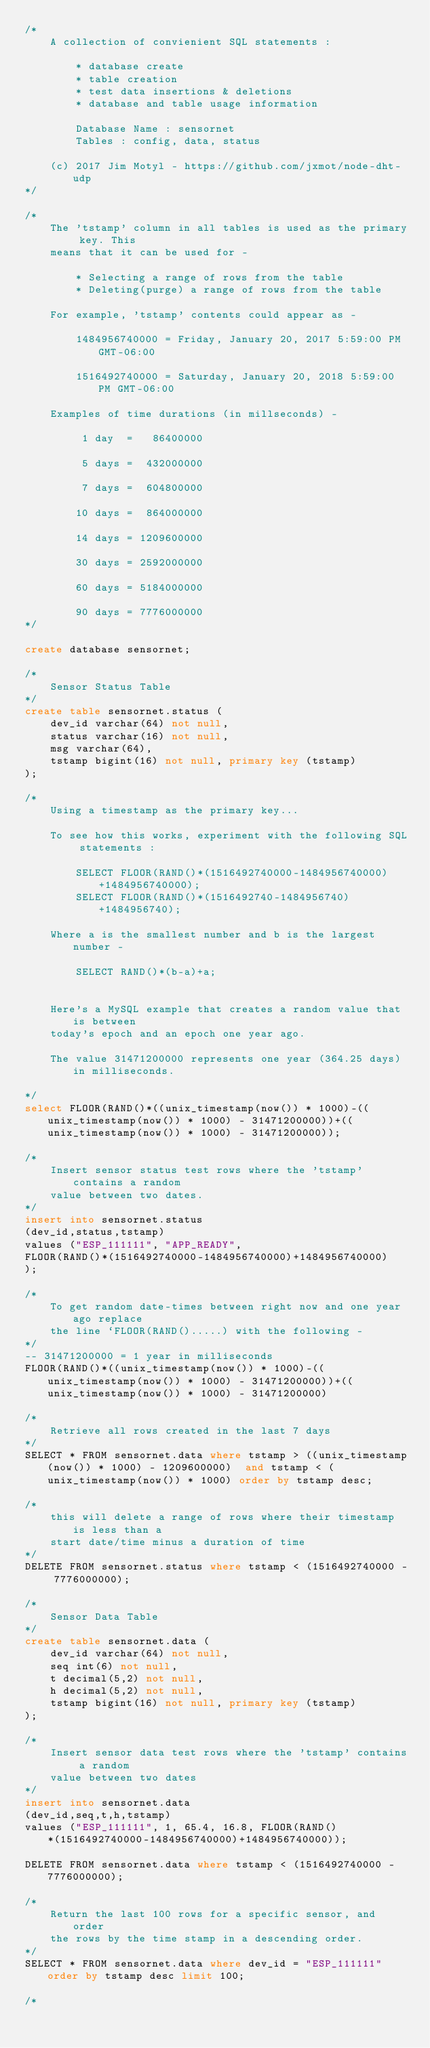<code> <loc_0><loc_0><loc_500><loc_500><_SQL_>/*
    A collection of convienient SQL statements :

        * database create
        * table creation
        * test data insertions & deletions
        * database and table usage information

        Database Name : sensornet
        Tables : config, data, status

    (c) 2017 Jim Motyl - https://github.com/jxmot/node-dht-udp
*/

/*
    The 'tstamp' column in all tables is used as the primary key. This 
    means that it can be used for - 

        * Selecting a range of rows from the table
        * Deleting(purge) a range of rows from the table

    For example, 'tstamp' contents could appear as - 

        1484956740000 = Friday, January 20, 2017 5:59:00 PM GMT-06:00
        
        1516492740000 = Saturday, January 20, 2018 5:59:00 PM GMT-06:00

    Examples of time durations (in millseconds) -

         1 day  =   86400000
        
         5 days =  432000000

         7 days =  604800000
        
        10 days =  864000000
        
        14 days = 1209600000
        
        30 days = 2592000000
        
        60 days = 5184000000
        
        90 days = 7776000000
*/

create database sensornet;

/*
    Sensor Status Table
*/
create table sensornet.status (
    dev_id varchar(64) not null,
    status varchar(16) not null,
    msg varchar(64),
    tstamp bigint(16) not null, primary key (tstamp) 
);

/*
    Using a timestamp as the primary key...

    To see how this works, experiment with the following SQL statements :

        SELECT FLOOR(RAND()*(1516492740000-1484956740000)+1484956740000);
        SELECT FLOOR(RAND()*(1516492740-1484956740)+1484956740);

    Where a is the smallest number and b is the largest number - 

        SELECT RAND()*(b-a)+a;


    Here's a MySQL example that creates a random value that is between
    today's epoch and an epoch one year ago.

    The value 31471200000 represents one year (364.25 days) in milliseconds.

*/
select FLOOR(RAND()*((unix_timestamp(now()) * 1000)-((unix_timestamp(now()) * 1000) - 31471200000))+((unix_timestamp(now()) * 1000) - 31471200000));

/*
    Insert sensor status test rows where the 'tstamp' contains a random
    value between two dates.
*/
insert into sensornet.status 
(dev_id,status,tstamp)
values ("ESP_111111", "APP_READY", 
FLOOR(RAND()*(1516492740000-1484956740000)+1484956740000)
);

/*
    To get random date-times between right now and one year ago replace
    the line `FLOOR(RAND().....) with the following - 
*/
-- 31471200000 = 1 year in milliseconds
FLOOR(RAND()*((unix_timestamp(now()) * 1000)-((unix_timestamp(now()) * 1000) - 31471200000))+((unix_timestamp(now()) * 1000) - 31471200000)

/*
    Retrieve all rows created in the last 7 days
*/
SELECT * FROM sensornet.data where tstamp > ((unix_timestamp(now()) * 1000) - 1209600000)  and tstamp < (unix_timestamp(now()) * 1000) order by tstamp desc;

/*
    this will delete a range of rows where their timestamp is less than a
    start date/time minus a duration of time
*/
DELETE FROM sensornet.status where tstamp < (1516492740000 - 7776000000);

/*
    Sensor Data Table
*/
create table sensornet.data (
    dev_id varchar(64) not null,
    seq int(6) not null,
    t decimal(5,2) not null,
    h decimal(5,2) not null,
    tstamp bigint(16) not null, primary key (tstamp) 
);

/*
    Insert sensor data test rows where the 'tstamp' contains a random
    value between two dates
*/
insert into sensornet.data 
(dev_id,seq,t,h,tstamp)
values ("ESP_111111", 1, 65.4, 16.8, FLOOR(RAND()*(1516492740000-1484956740000)+1484956740000));

DELETE FROM sensornet.data where tstamp < (1516492740000 - 7776000000);

/*
    Return the last 100 rows for a specific sensor, and order 
    the rows by the time stamp in a descending order.
*/
SELECT * FROM sensornet.data where dev_id = "ESP_111111" order by tstamp desc limit 100;

/*</code> 